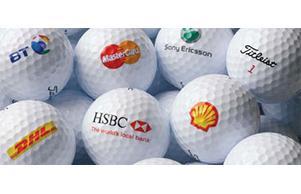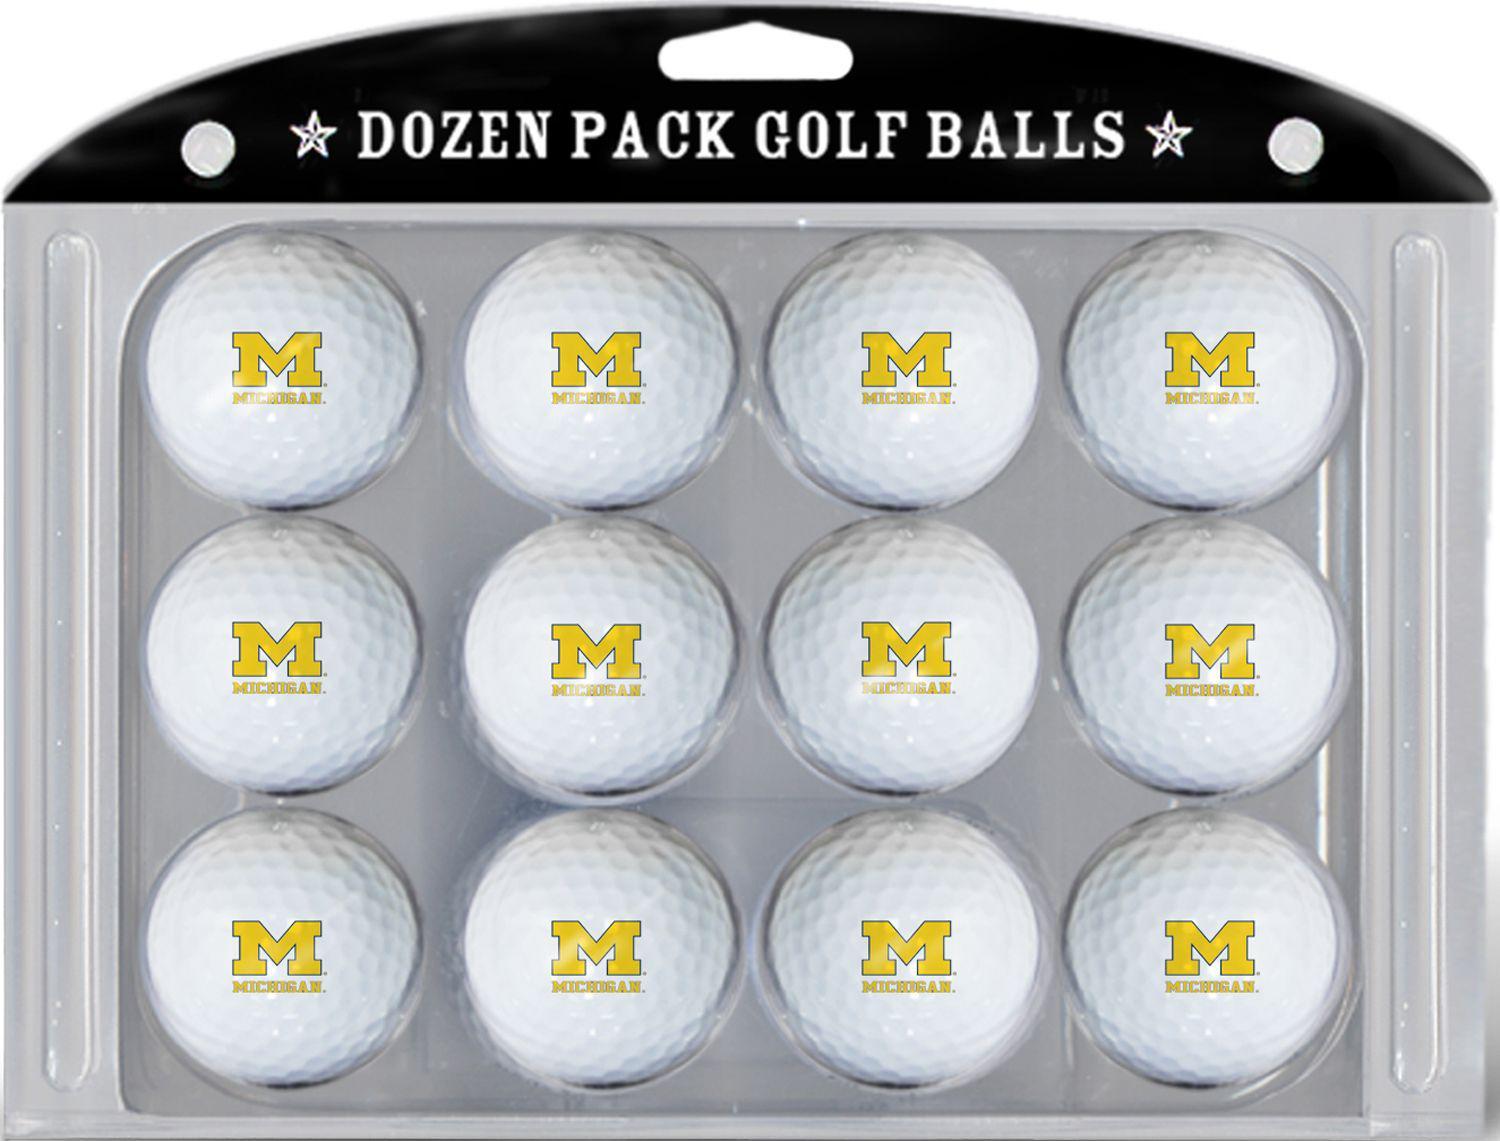The first image is the image on the left, the second image is the image on the right. Examine the images to the left and right. Is the description "In one of the images, 12 golf balls are lined up neatly in a 3x4 or 4x3 pattern." accurate? Answer yes or no. Yes. The first image is the image on the left, the second image is the image on the right. Assess this claim about the two images: "In at least one image there is a total of 12 golf balls.". Correct or not? Answer yes or no. Yes. 